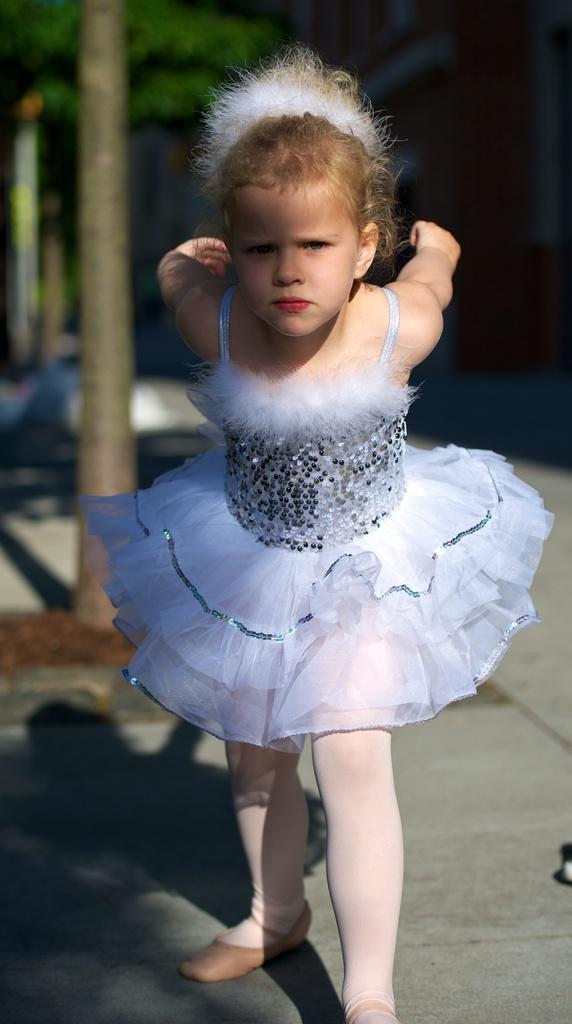How would you summarize this image in a sentence or two? In this picture we can see a girl wearing a beautiful white frock. In the background we can see a tree. This is a road. 